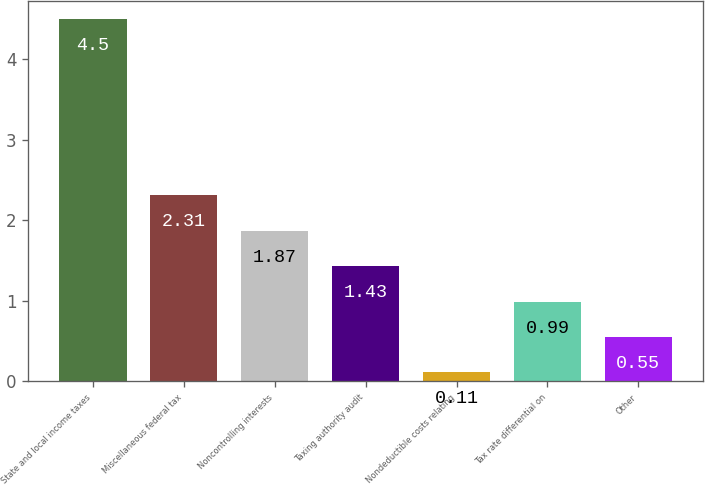<chart> <loc_0><loc_0><loc_500><loc_500><bar_chart><fcel>State and local income taxes<fcel>Miscellaneous federal tax<fcel>Noncontrolling interests<fcel>Taxing authority audit<fcel>Nondeductible costs relating<fcel>Tax rate differential on<fcel>Other<nl><fcel>4.5<fcel>2.31<fcel>1.87<fcel>1.43<fcel>0.11<fcel>0.99<fcel>0.55<nl></chart> 